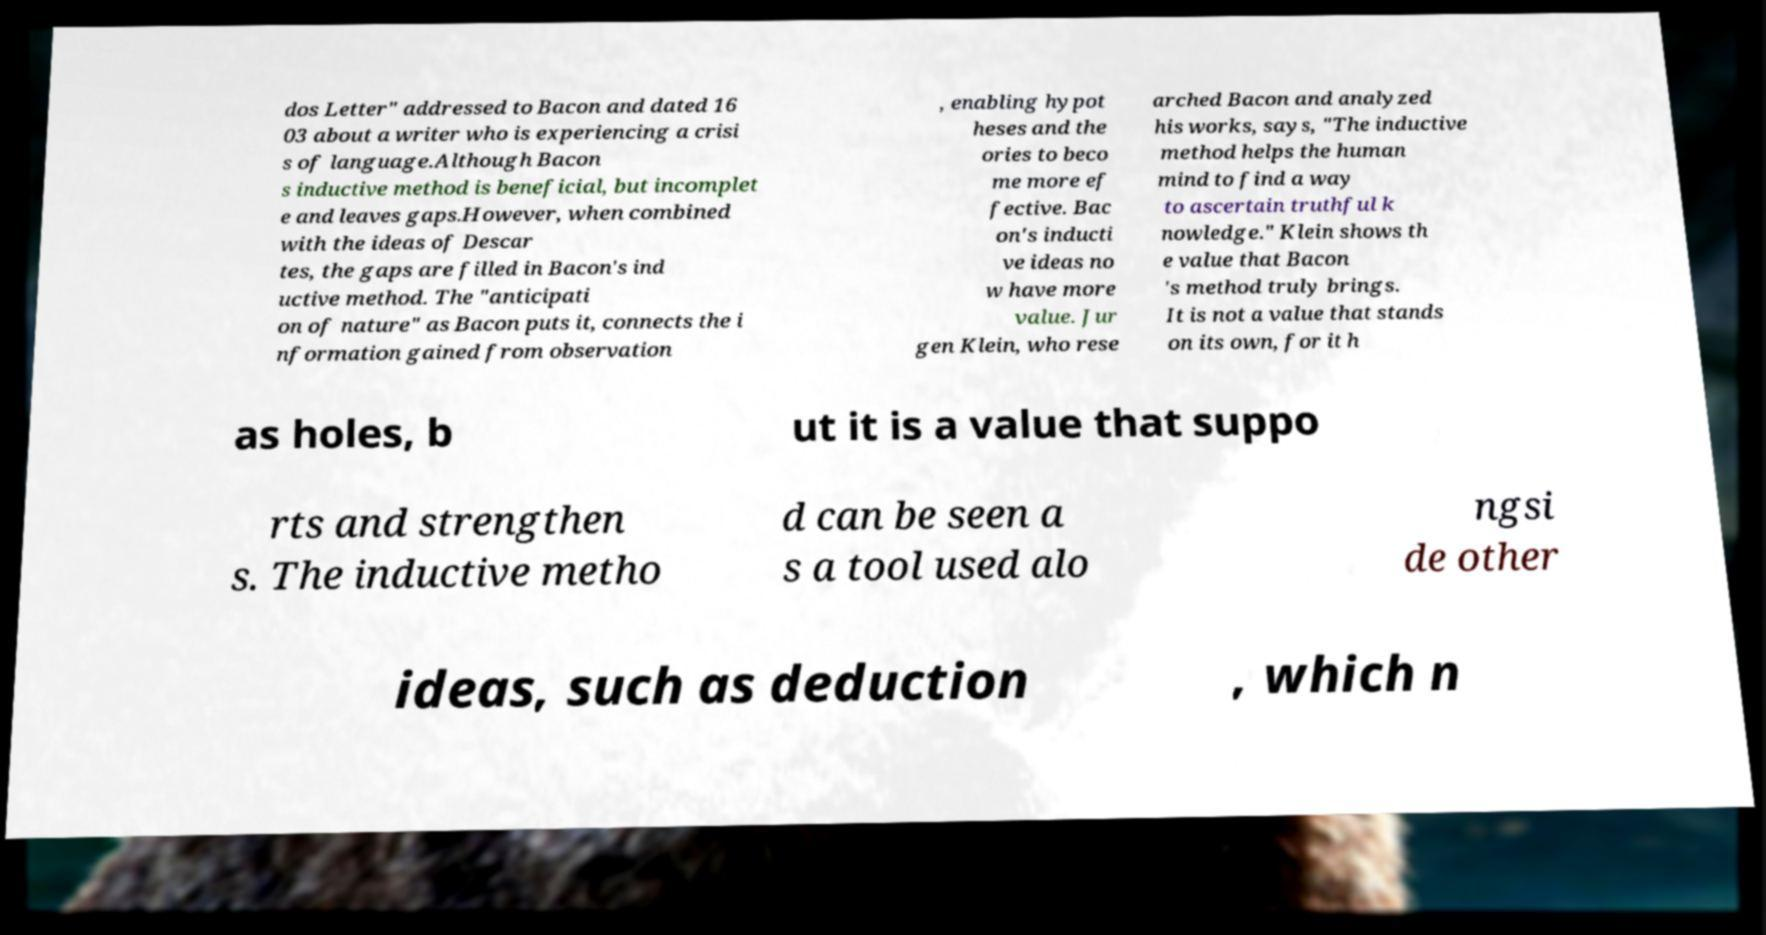There's text embedded in this image that I need extracted. Can you transcribe it verbatim? dos Letter" addressed to Bacon and dated 16 03 about a writer who is experiencing a crisi s of language.Although Bacon s inductive method is beneficial, but incomplet e and leaves gaps.However, when combined with the ideas of Descar tes, the gaps are filled in Bacon's ind uctive method. The "anticipati on of nature" as Bacon puts it, connects the i nformation gained from observation , enabling hypot heses and the ories to beco me more ef fective. Bac on's inducti ve ideas no w have more value. Jur gen Klein, who rese arched Bacon and analyzed his works, says, "The inductive method helps the human mind to find a way to ascertain truthful k nowledge." Klein shows th e value that Bacon 's method truly brings. It is not a value that stands on its own, for it h as holes, b ut it is a value that suppo rts and strengthen s. The inductive metho d can be seen a s a tool used alo ngsi de other ideas, such as deduction , which n 